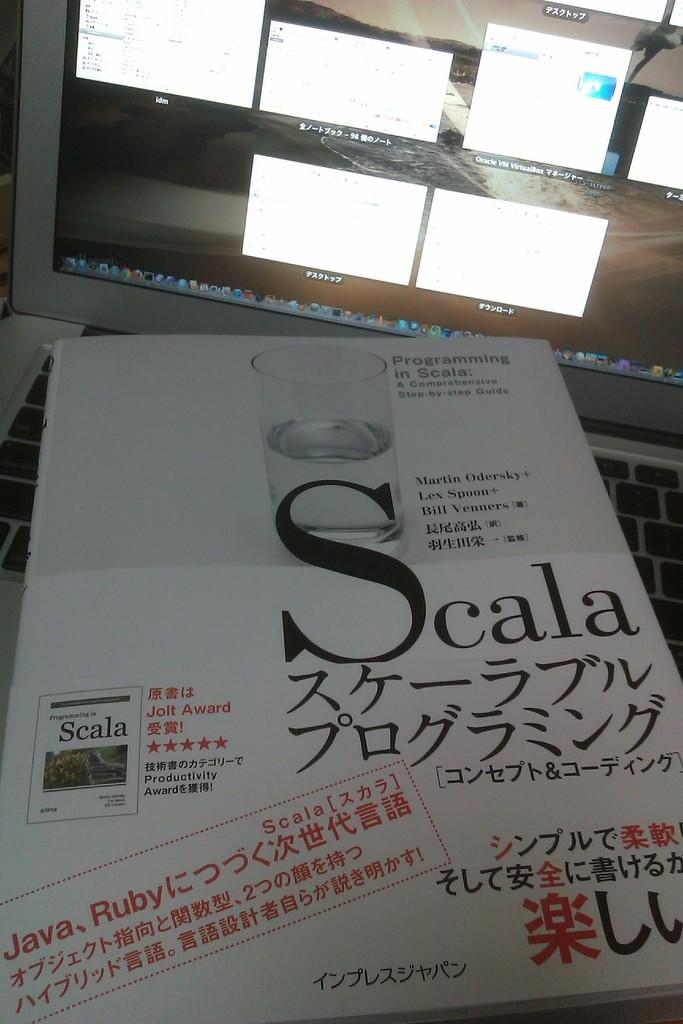What is the brand?
Provide a short and direct response. Scala. Thiis is paper?
Offer a very short reply. Yes. 